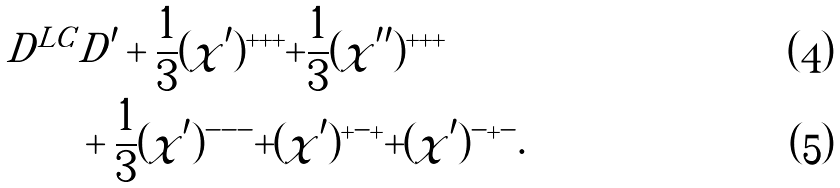Convert formula to latex. <formula><loc_0><loc_0><loc_500><loc_500>D ^ { L C } & D ^ { \prime } + \frac { 1 } { 3 } ( \chi ^ { \prime } ) ^ { + + + } + \frac { 1 } { 3 } ( \chi ^ { \prime \prime } ) ^ { + + + } \\ & + \frac { 1 } { 3 } ( \chi ^ { \prime } ) ^ { - - - } + ( \chi ^ { \prime } ) ^ { + - + } + ( \chi ^ { \prime } ) ^ { - + - } .</formula> 